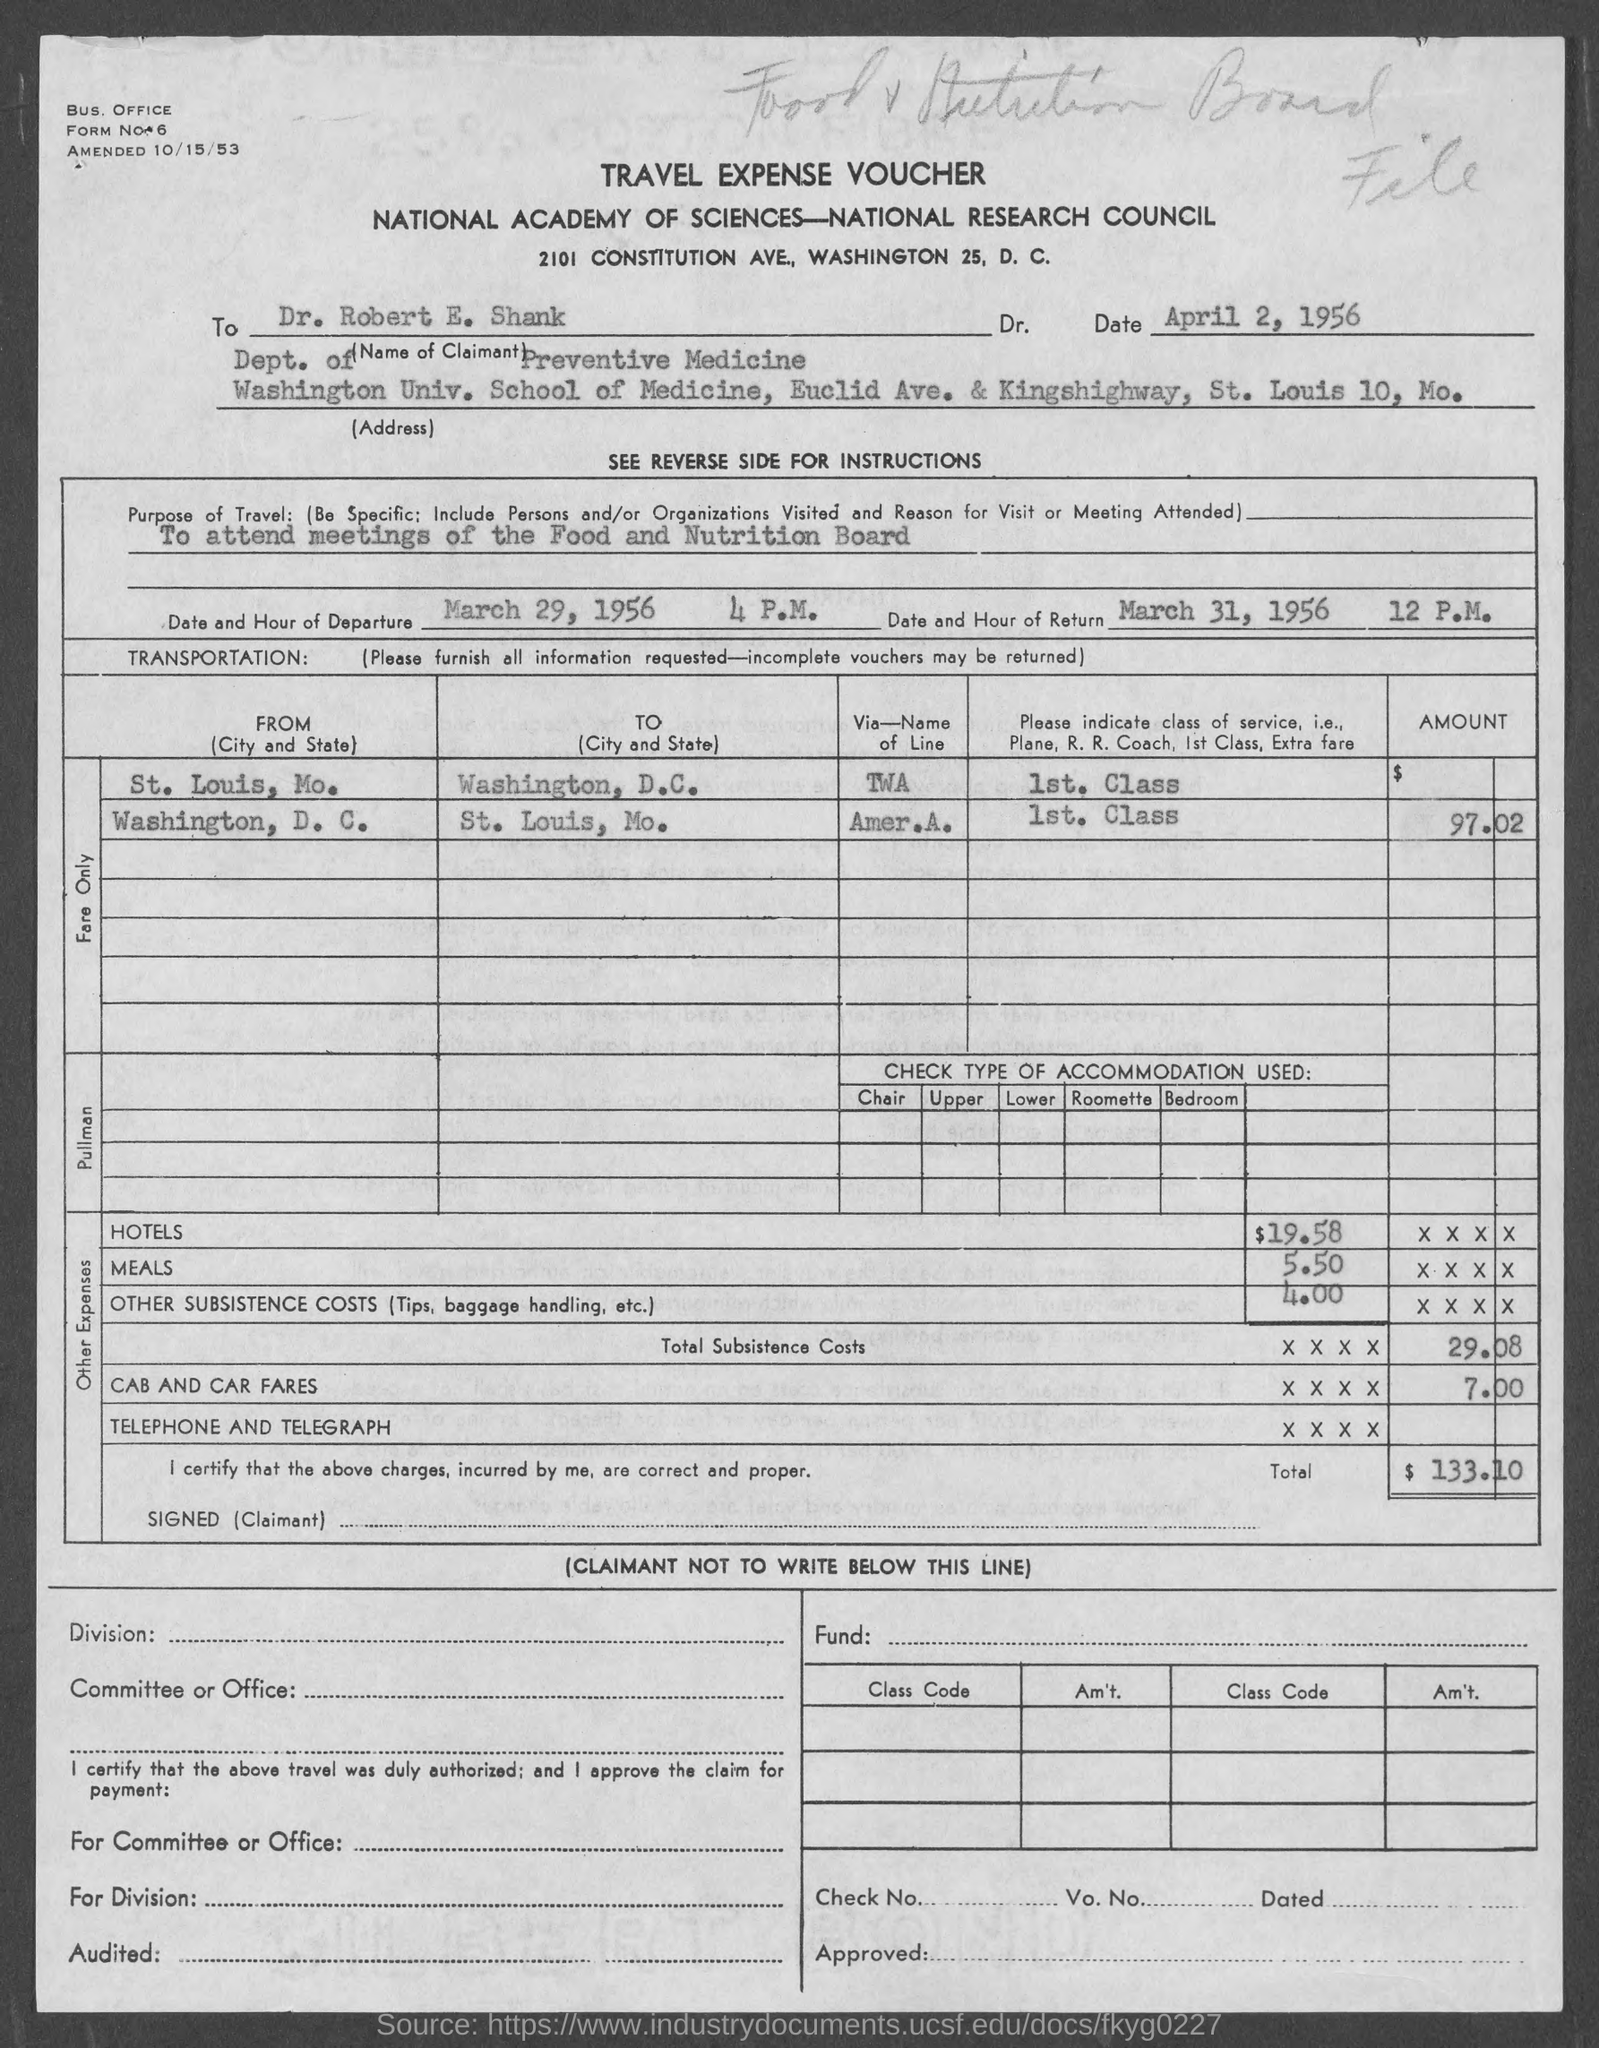What is the document about?
Ensure brevity in your answer.  TRAVEL EXPENSE VOUCHER. When was the form amended?
Your answer should be compact. 10/15/53. To whom is the form addressed?
Provide a short and direct response. Dr. Robert E. Shank. What is the purpose of travel?
Keep it short and to the point. To attend meetings of the Food and Nutrition Board. What is the date of departure?
Your response must be concise. March 29, 1956. When is the hour of return?
Offer a terse response. 12 P.M. Which department is Dr. Robert E. Shank from?
Offer a terse response. Dept. of Preventive Medicine. Which University is Dr. Robert from?
Your answer should be very brief. Washington. 